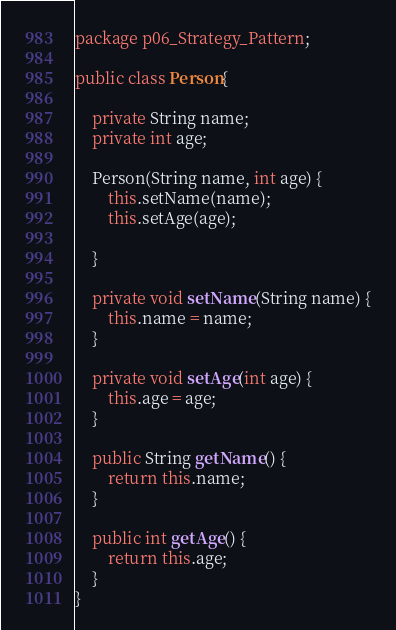<code> <loc_0><loc_0><loc_500><loc_500><_Java_>package p06_Strategy_Pattern;

public class Person{

    private String name;
    private int age;

    Person(String name, int age) {
        this.setName(name);
        this.setAge(age);

    }

    private void setName(String name) {
        this.name = name;
    }

    private void setAge(int age) {
        this.age = age;
    }

    public String getName() {
        return this.name;
    }

    public int getAge() {
        return this.age;
    }
}
</code> 